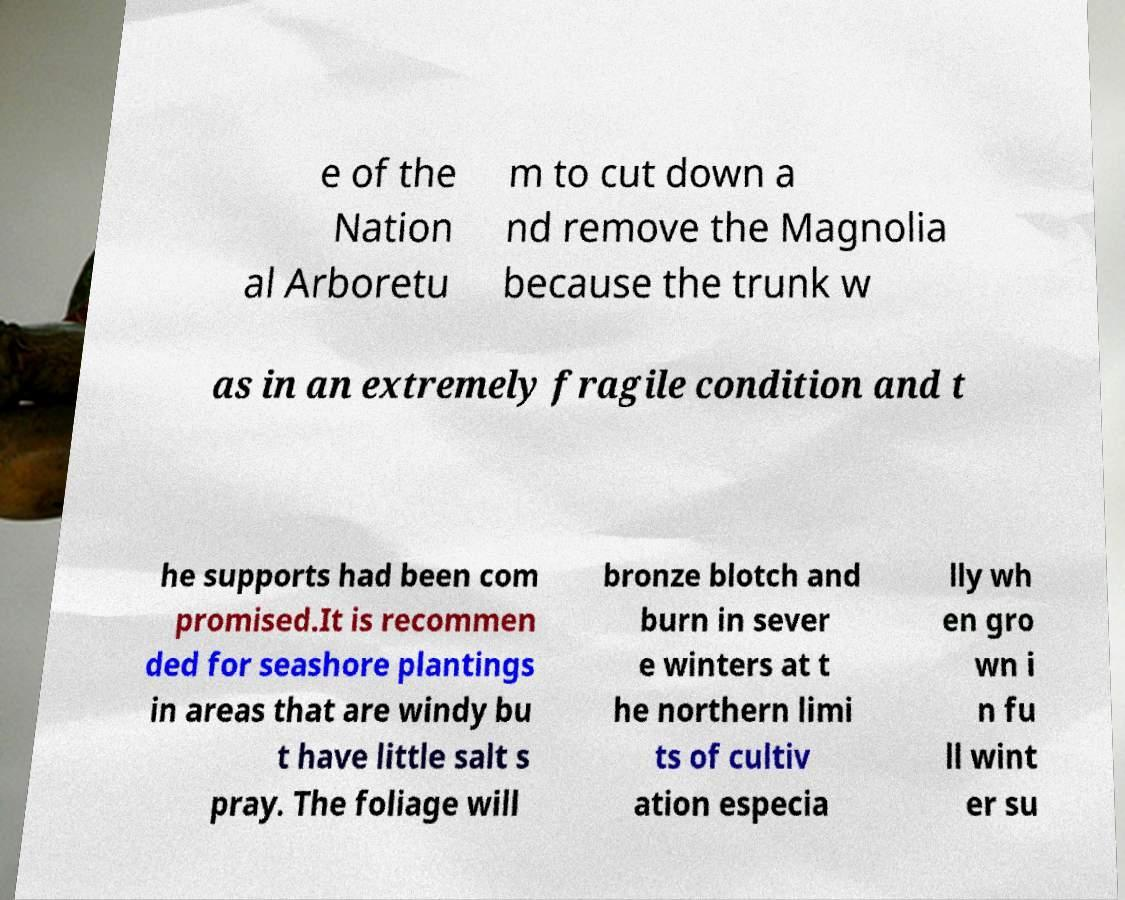Please read and relay the text visible in this image. What does it say? e of the Nation al Arboretu m to cut down a nd remove the Magnolia because the trunk w as in an extremely fragile condition and t he supports had been com promised.It is recommen ded for seashore plantings in areas that are windy bu t have little salt s pray. The foliage will bronze blotch and burn in sever e winters at t he northern limi ts of cultiv ation especia lly wh en gro wn i n fu ll wint er su 